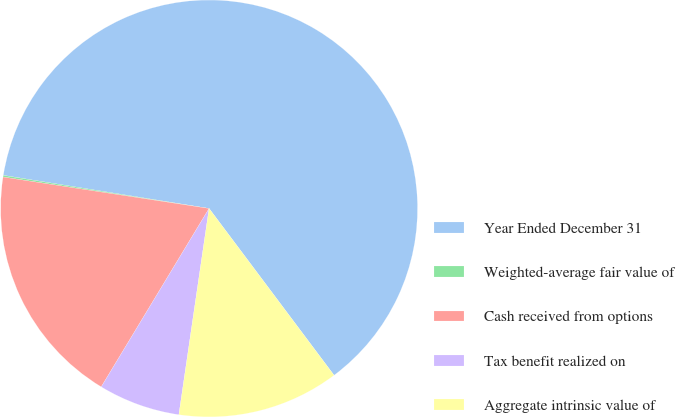Convert chart to OTSL. <chart><loc_0><loc_0><loc_500><loc_500><pie_chart><fcel>Year Ended December 31<fcel>Weighted-average fair value of<fcel>Cash received from options<fcel>Tax benefit realized on<fcel>Aggregate intrinsic value of<nl><fcel>62.23%<fcel>0.13%<fcel>18.76%<fcel>6.34%<fcel>12.55%<nl></chart> 